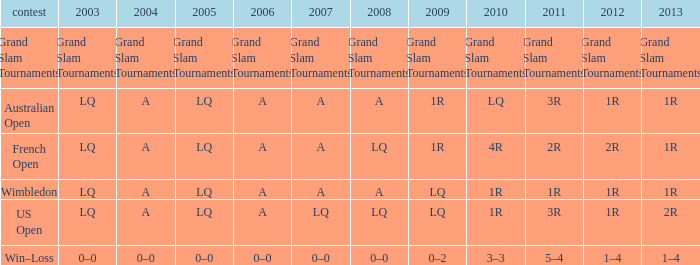Which tournament has a 2013 of 1r, and a 2012 of 1r? Australian Open, Wimbledon. 